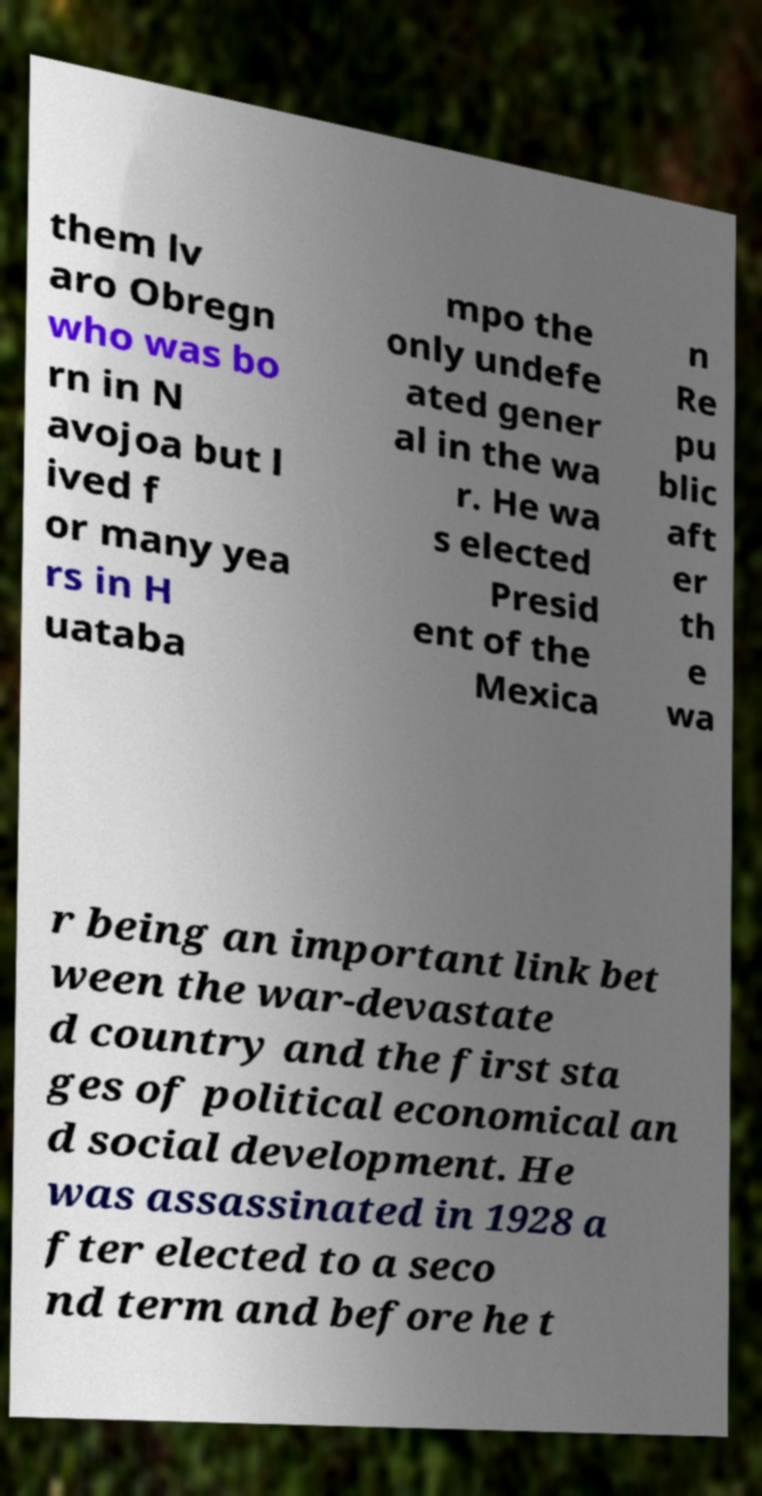There's text embedded in this image that I need extracted. Can you transcribe it verbatim? them lv aro Obregn who was bo rn in N avojoa but l ived f or many yea rs in H uataba mpo the only undefe ated gener al in the wa r. He wa s elected Presid ent of the Mexica n Re pu blic aft er th e wa r being an important link bet ween the war-devastate d country and the first sta ges of political economical an d social development. He was assassinated in 1928 a fter elected to a seco nd term and before he t 